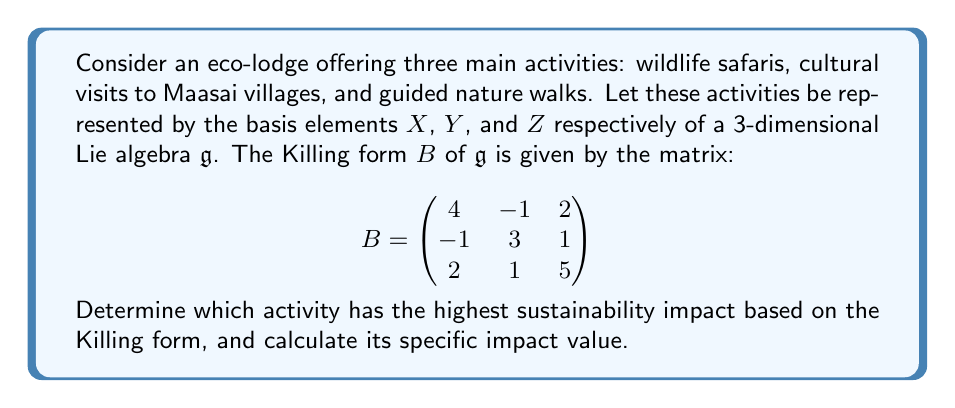Help me with this question. To analyze the sustainability impact of the eco-tourism activities using the Killing form, we need to understand that in this context, the Killing form represents the relative sustainability impact of each activity and their interactions.

1) First, we need to interpret the Killing form matrix:
   - The diagonal elements represent the direct sustainability impact of each activity.
   - The off-diagonal elements represent the interactions between activities.

2) The diagonal elements of the Killing form matrix are:
   - $B(X,X) = 4$ for wildlife safaris
   - $B(Y,Y) = 3$ for cultural visits
   - $B(Z,Z) = 5$ for guided nature walks

3) The largest diagonal element corresponds to the activity with the highest sustainability impact. In this case, it's $B(Z,Z) = 5$, which represents guided nature walks.

4) To calculate the specific impact value of guided nature walks, we need to consider not just its direct impact but also its interactions with other activities. This is done by summing the entire row (or column) corresponding to Z:

   Impact value of Z = $B(Z,X) + B(Z,Y) + B(Z,Z) = 2 + 1 + 5 = 8$

Therefore, guided nature walks have the highest sustainability impact with a specific impact value of 8.
Answer: Guided nature walks have the highest sustainability impact with a specific impact value of 8. 